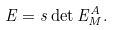Convert formula to latex. <formula><loc_0><loc_0><loc_500><loc_500>E = s \det E ^ { A } _ { M } .</formula> 